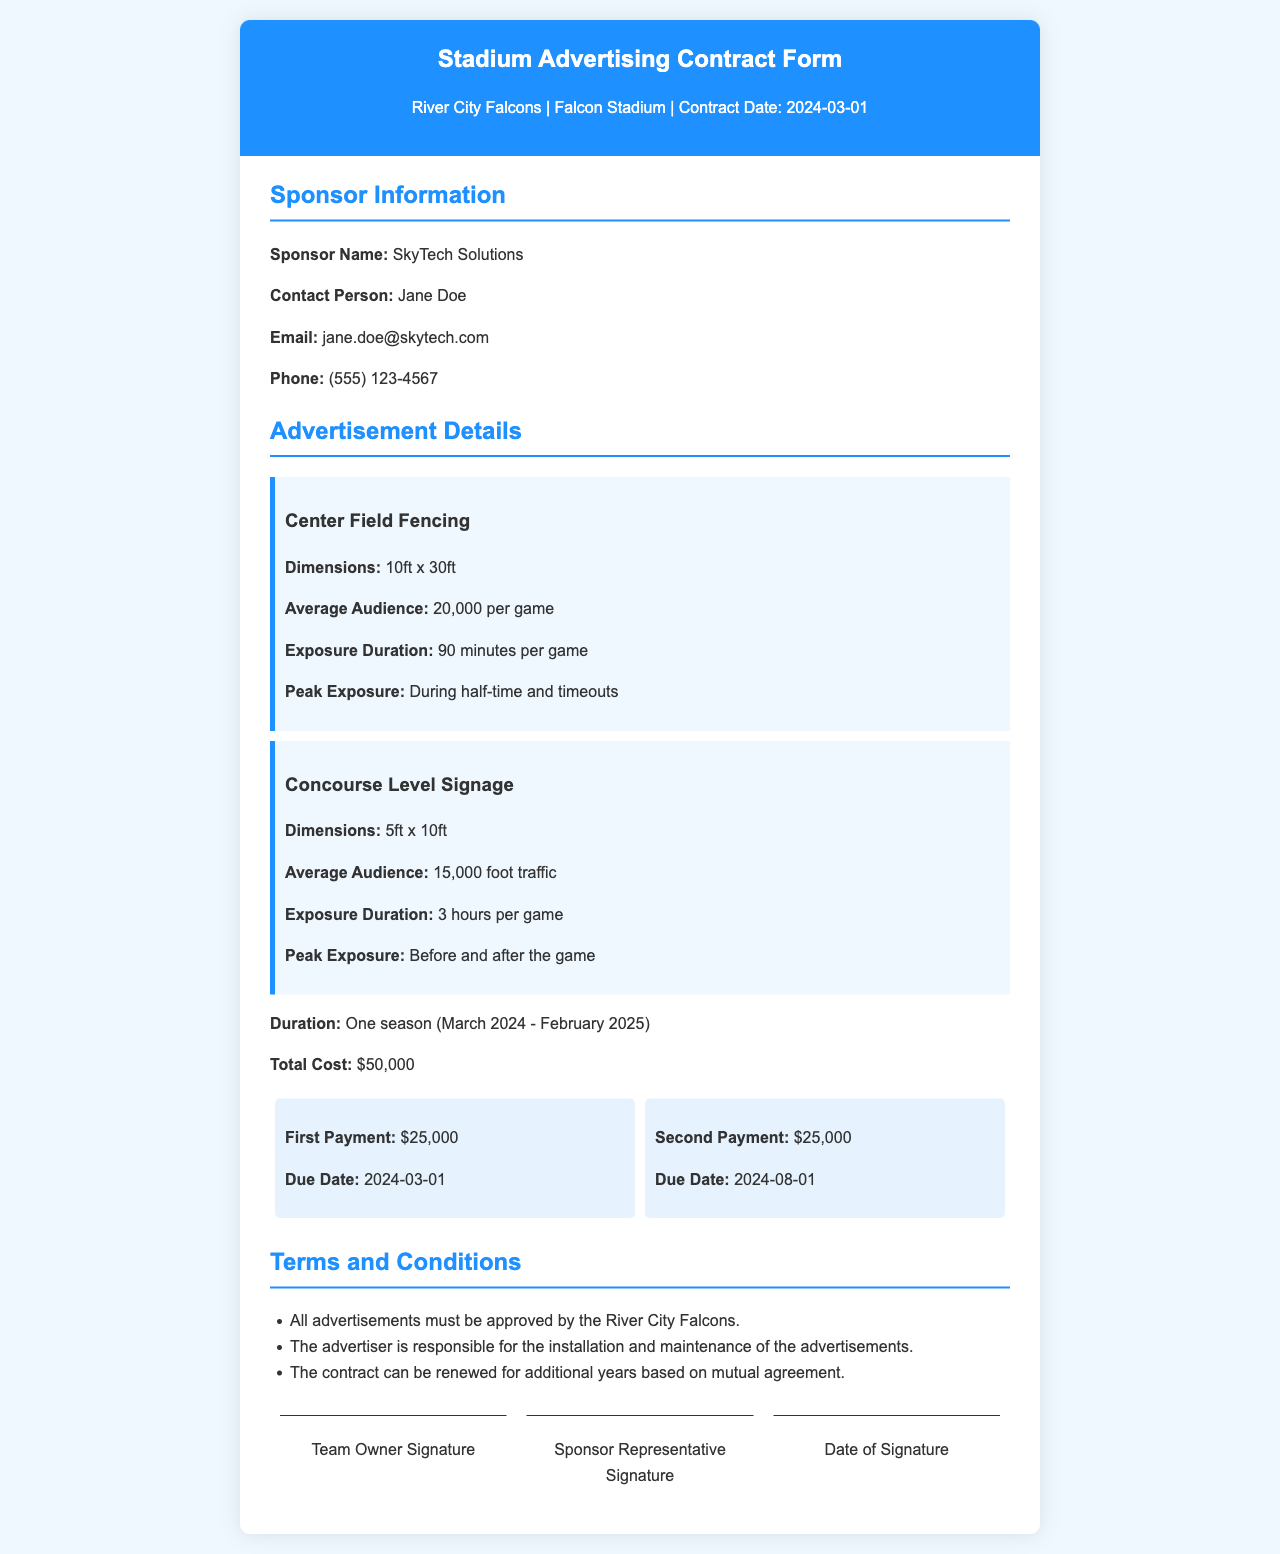what is the name of the sponsor? The name of the sponsor is clearly stated in the document as "SkyTech Solutions."
Answer: SkyTech Solutions who is the contact person for the sponsor? The document lists the contact person as "Jane Doe."
Answer: Jane Doe what is the total cost of the advertising contract? The total cost is specified in the document as "$50,000."
Answer: $50,000 what is the exposure duration for the concourse level signage? It is indicated that the exposure duration for the concourse level signage is "3 hours per game."
Answer: 3 hours per game when is the second payment due? The due date for the second payment is mentioned in the payment schedule as "2024-08-01."
Answer: 2024-08-01 how many advertisements are listed in the document? The document contains two advertisements: "Center Field Fencing" and "Concourse Level Signage."
Answer: 2 what are the dimensions of the center field fencing advertisement? The dimensions for the center field fencing advertisement are specified as "10ft x 30ft."
Answer: 10ft x 30ft what is the peak exposure time for advertisements? The peak exposure times mentioned for the advertisements are "During half-time and timeouts" for center field fencing, and "Before and after the game" for concourse level signage.
Answer: During half-time and timeouts; Before and after the game what is stated regarding the approval of advertisements? The document states, "All advertisements must be approved by the River City Falcons."
Answer: All advertisements must be approved by the River City Falcons 